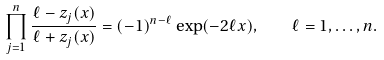Convert formula to latex. <formula><loc_0><loc_0><loc_500><loc_500>\prod _ { j = 1 } ^ { n } \frac { \ell - z _ { j } ( x ) } { \ell + z _ { j } ( x ) } = ( - 1 ) ^ { n - \ell } \exp ( - 2 \ell x ) , \quad \ell = 1 , \dots , n .</formula> 